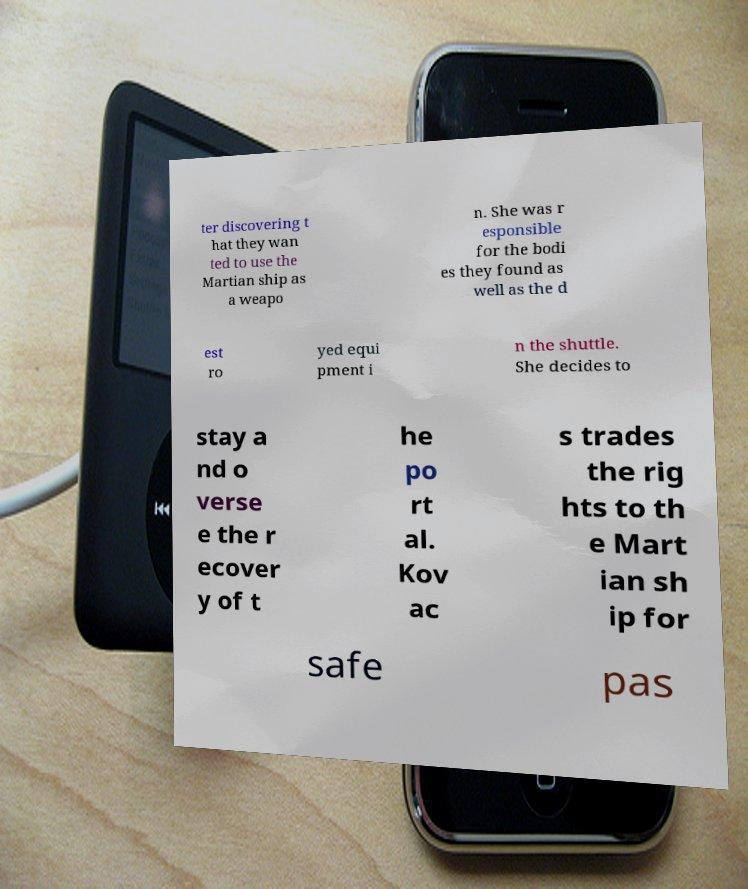I need the written content from this picture converted into text. Can you do that? ter discovering t hat they wan ted to use the Martian ship as a weapo n. She was r esponsible for the bodi es they found as well as the d est ro yed equi pment i n the shuttle. She decides to stay a nd o verse e the r ecover y of t he po rt al. Kov ac s trades the rig hts to th e Mart ian sh ip for safe pas 